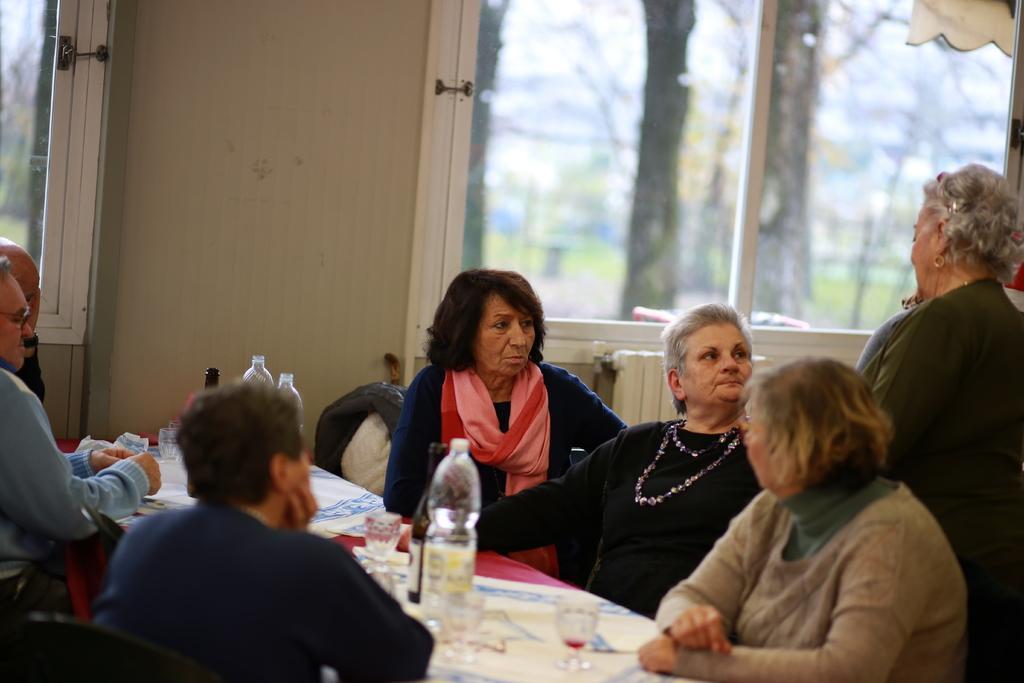Please provide a concise description of this image. In this picture there are group of people sitting besides a table, towards the left there are three persons, towards the right there are four people. A woman in the right corner, she is wearing a green dress, earrings and goggles. A woman in the center she is wearing a pink scarf. On the table there are glasses and bottles. In the background there is a window, through the window there are some trees. 